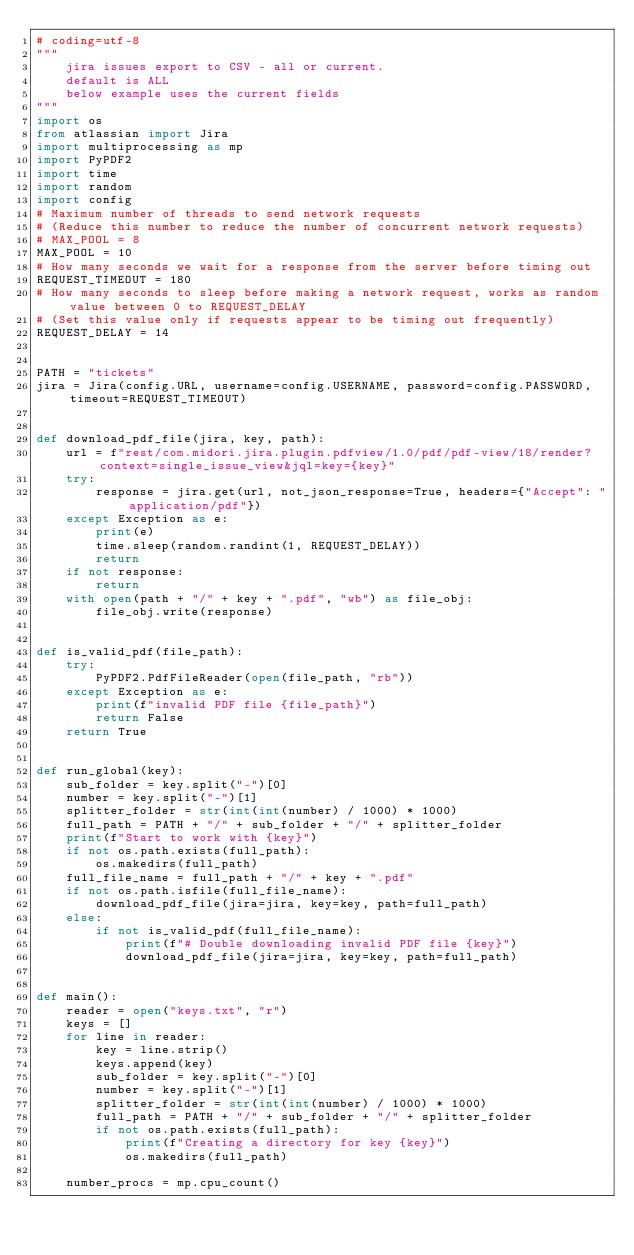<code> <loc_0><loc_0><loc_500><loc_500><_Python_># coding=utf-8
"""
    jira issues export to CSV - all or current.
    default is ALL
    below example uses the current fields
"""
import os
from atlassian import Jira
import multiprocessing as mp
import PyPDF2
import time
import random
import config
# Maximum number of threads to send network requests
# (Reduce this number to reduce the number of concurrent network requests)
# MAX_POOL = 8
MAX_POOL = 10
# How many seconds we wait for a response from the server before timing out
REQUEST_TIMEOUT = 180
# How many seconds to sleep before making a network request, works as random value between 0 to REQUEST_DELAY
# (Set this value only if requests appear to be timing out frequently)
REQUEST_DELAY = 14


PATH = "tickets"
jira = Jira(config.URL, username=config.USERNAME, password=config.PASSWORD, timeout=REQUEST_TIMEOUT)


def download_pdf_file(jira, key, path):
    url = f"rest/com.midori.jira.plugin.pdfview/1.0/pdf/pdf-view/18/render?context=single_issue_view&jql=key={key}"
    try:
        response = jira.get(url, not_json_response=True, headers={"Accept": "application/pdf"})
    except Exception as e:
        print(e)
        time.sleep(random.randint(1, REQUEST_DELAY))
        return
    if not response:
        return
    with open(path + "/" + key + ".pdf", "wb") as file_obj:
        file_obj.write(response)


def is_valid_pdf(file_path):
    try:
        PyPDF2.PdfFileReader(open(file_path, "rb"))
    except Exception as e:
        print(f"invalid PDF file {file_path}")
        return False
    return True


def run_global(key):
    sub_folder = key.split("-")[0]
    number = key.split("-")[1]
    splitter_folder = str(int(int(number) / 1000) * 1000)
    full_path = PATH + "/" + sub_folder + "/" + splitter_folder
    print(f"Start to work with {key}")
    if not os.path.exists(full_path):
        os.makedirs(full_path)
    full_file_name = full_path + "/" + key + ".pdf"
    if not os.path.isfile(full_file_name):
        download_pdf_file(jira=jira, key=key, path=full_path)
    else:
        if not is_valid_pdf(full_file_name):
            print(f"# Double downloading invalid PDF file {key}")
            download_pdf_file(jira=jira, key=key, path=full_path)


def main():
    reader = open("keys.txt", "r")
    keys = []
    for line in reader:
        key = line.strip()
        keys.append(key)
        sub_folder = key.split("-")[0]
        number = key.split("-")[1]
        splitter_folder = str(int(int(number) / 1000) * 1000)
        full_path = PATH + "/" + sub_folder + "/" + splitter_folder
        if not os.path.exists(full_path):
            print(f"Creating a directory for key {key}")
            os.makedirs(full_path)

    number_procs = mp.cpu_count()</code> 